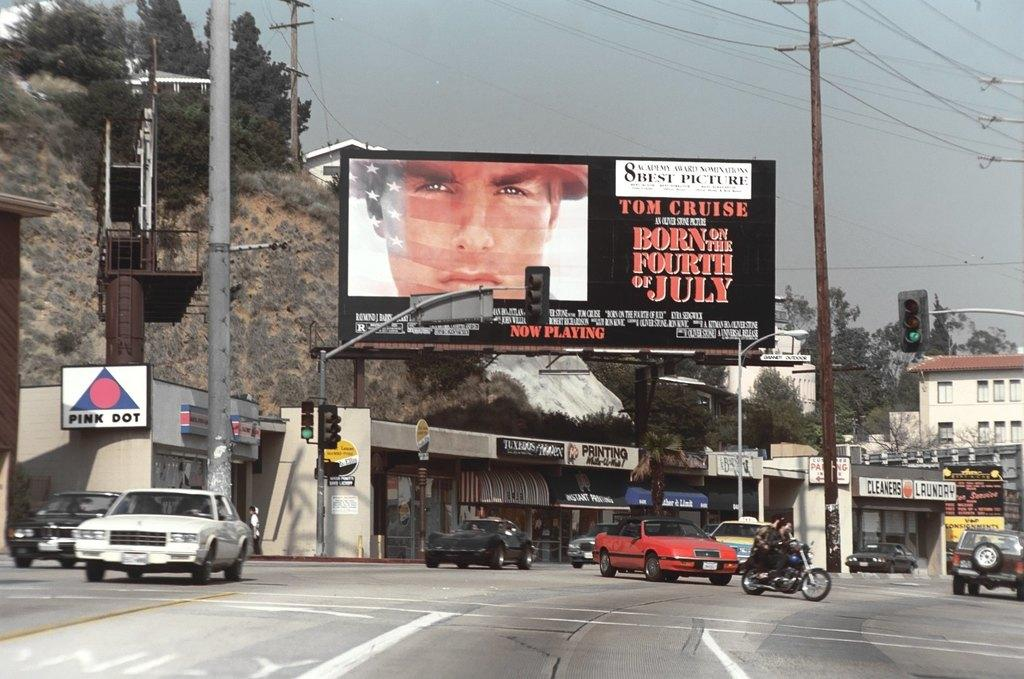Provide a one-sentence caption for the provided image. A billboard is posted for Tom Cruise in Born on the Fourth of July. 